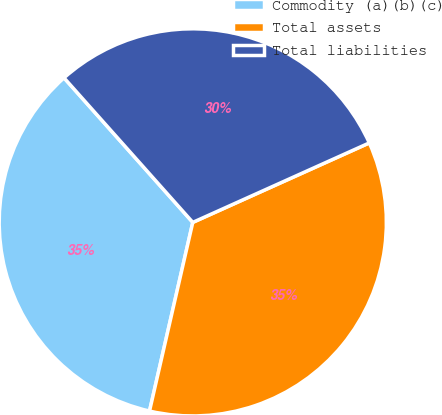Convert chart. <chart><loc_0><loc_0><loc_500><loc_500><pie_chart><fcel>Commodity (a)(b)(c)<fcel>Total assets<fcel>Total liabilities<nl><fcel>34.83%<fcel>35.32%<fcel>29.85%<nl></chart> 